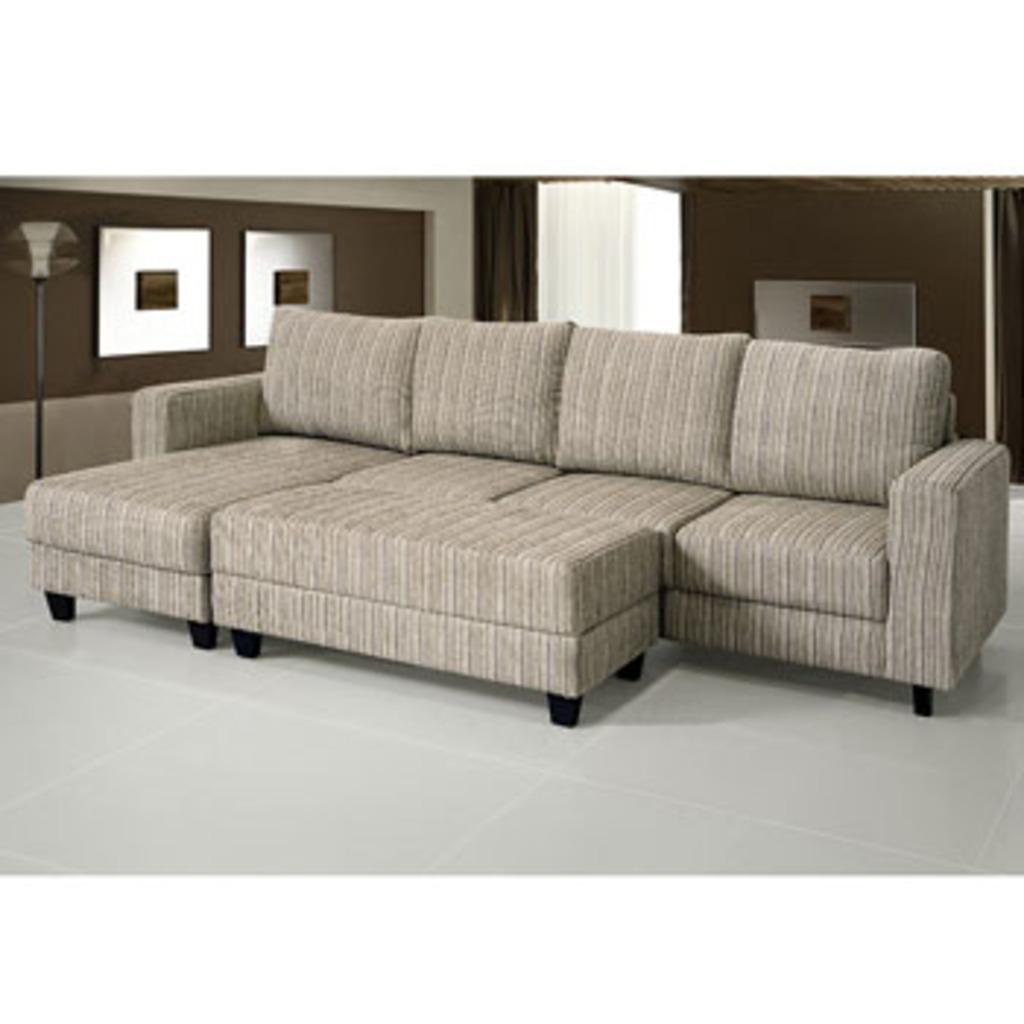How would you summarize this image in a sentence or two? This is inside of the room we can see sofa,chairs on the floor. On the background we can see curtains,wall. 